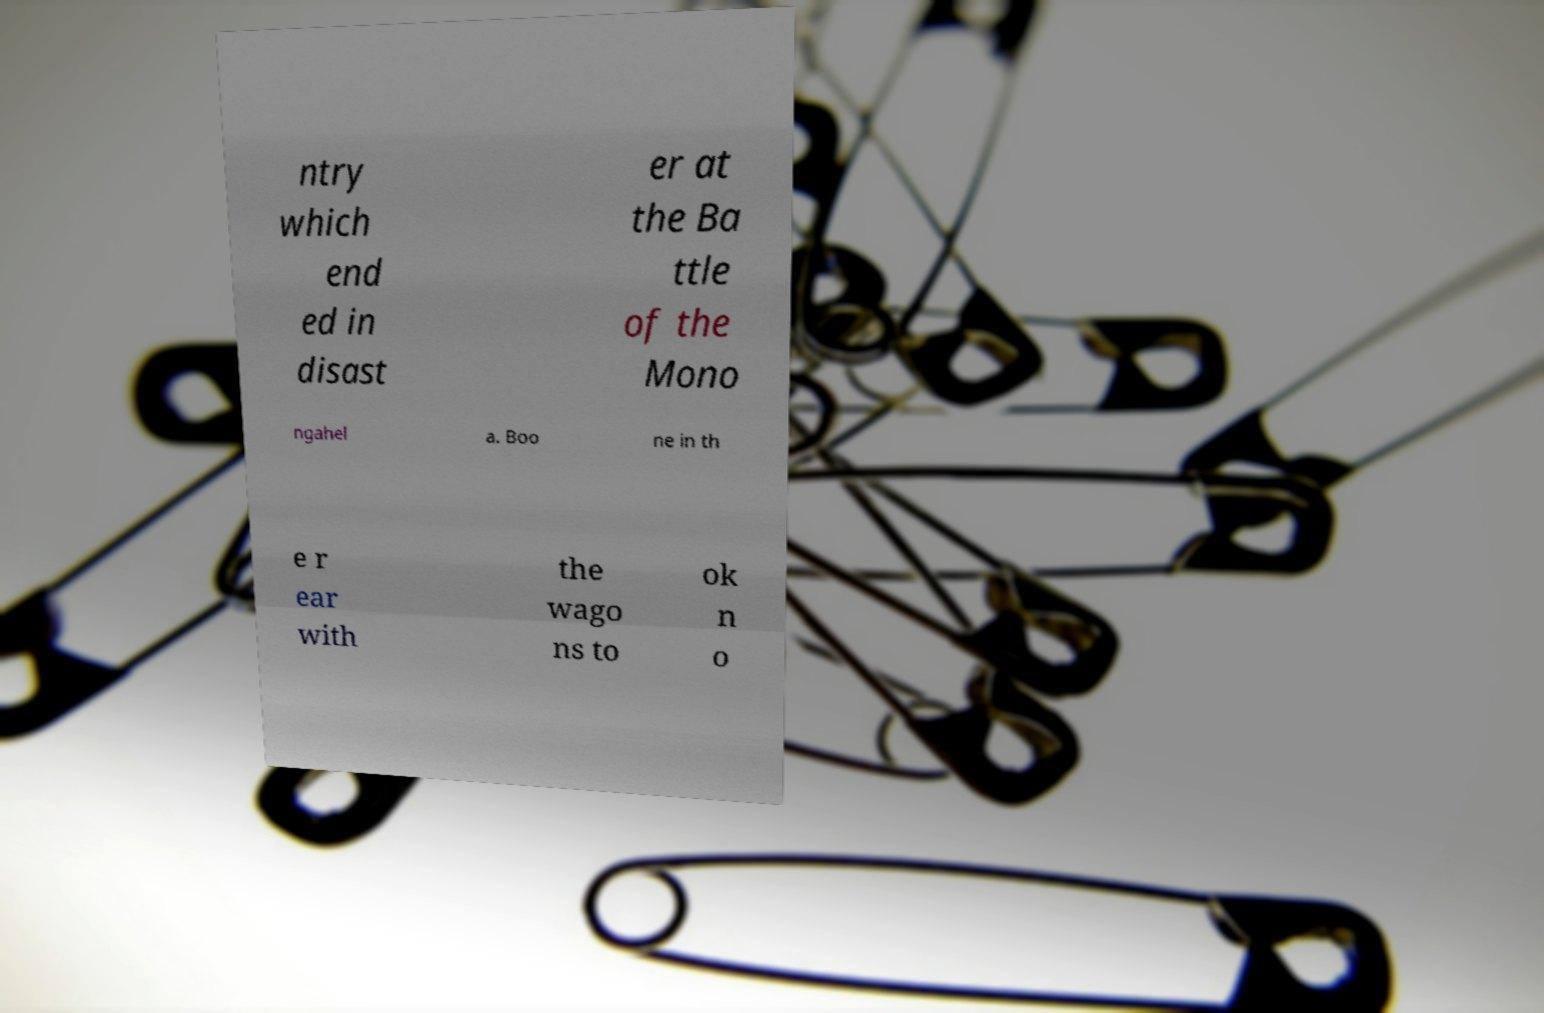Please read and relay the text visible in this image. What does it say? ntry which end ed in disast er at the Ba ttle of the Mono ngahel a. Boo ne in th e r ear with the wago ns to ok n o 